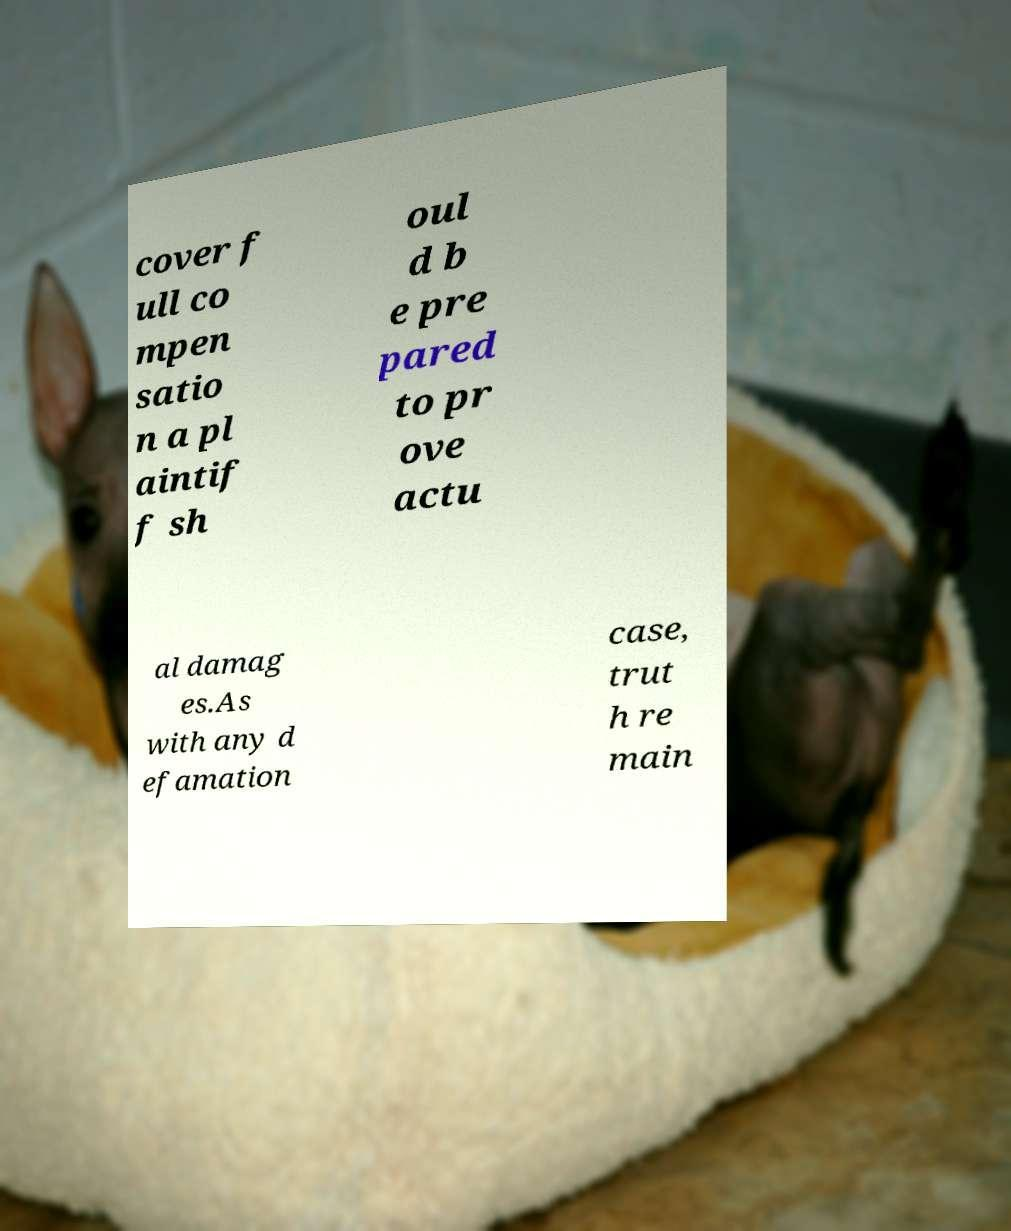Could you assist in decoding the text presented in this image and type it out clearly? cover f ull co mpen satio n a pl aintif f sh oul d b e pre pared to pr ove actu al damag es.As with any d efamation case, trut h re main 